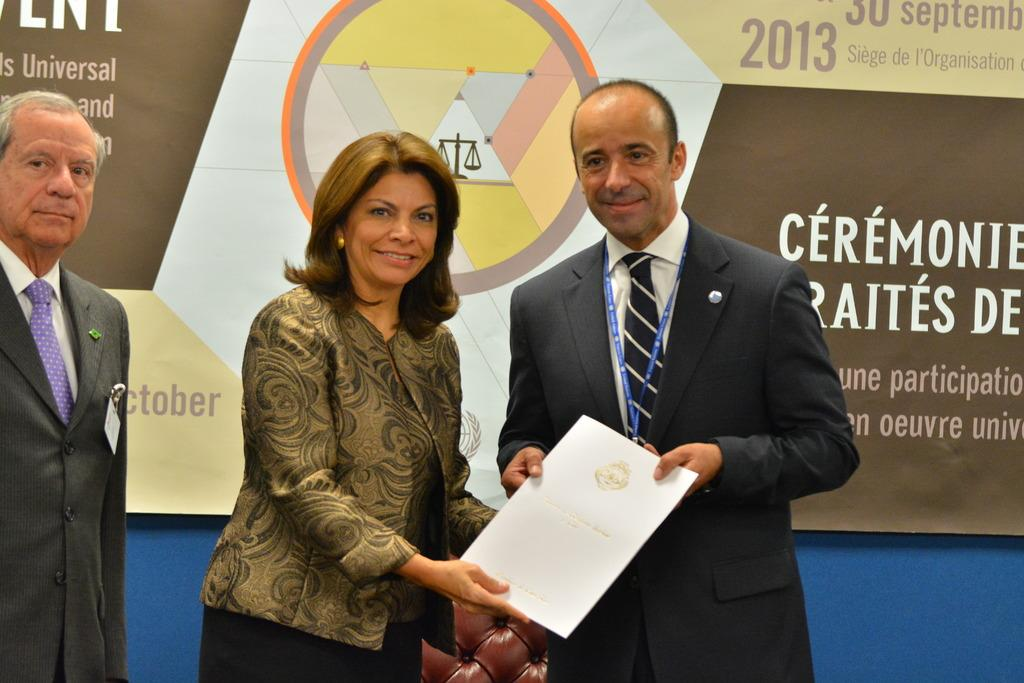How many people are in the image? There are three people standing in the image. What are two of the people holding? Two of the people are holding a paper that looks like a certificate. What piece of furniture is present in the image? There is a chair in the image. What can be seen on the board in the image? There is a board with some text in the image. How many knots are tied on the tongue of the person in the image? There is no person with a tongue tied in knots in the image. What number is written on the forehead of the person in the image? There is no number written on anyone's forehead in the image. 